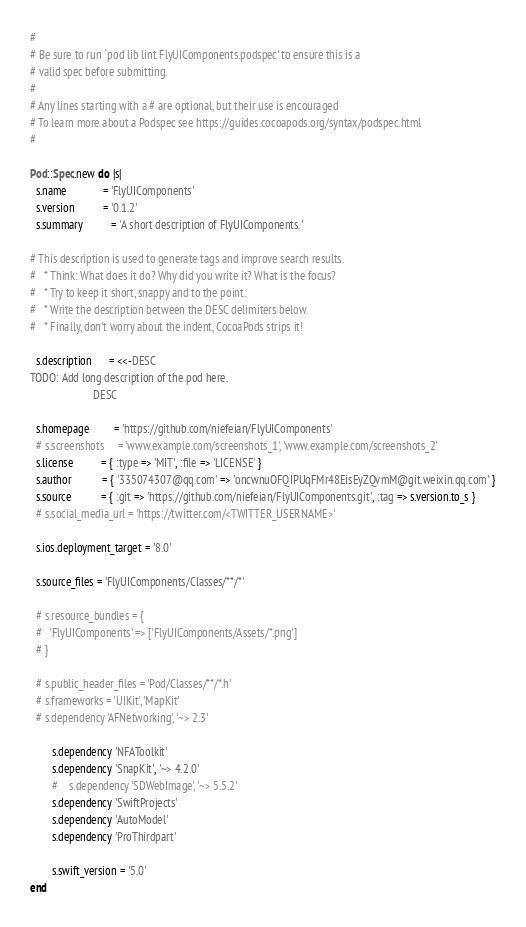Convert code to text. <code><loc_0><loc_0><loc_500><loc_500><_Ruby_>#
# Be sure to run `pod lib lint FlyUIComponents.podspec' to ensure this is a
# valid spec before submitting.
#
# Any lines starting with a # are optional, but their use is encouraged
# To learn more about a Podspec see https://guides.cocoapods.org/syntax/podspec.html
#

Pod::Spec.new do |s|
  s.name             = 'FlyUIComponents'
  s.version          = '0.1.2'
  s.summary          = 'A short description of FlyUIComponents.'

# This description is used to generate tags and improve search results.
#   * Think: What does it do? Why did you write it? What is the focus?
#   * Try to keep it short, snappy and to the point.
#   * Write the description between the DESC delimiters below.
#   * Finally, don't worry about the indent, CocoaPods strips it!

  s.description      = <<-DESC
TODO: Add long description of the pod here.
                       DESC

  s.homepage         = 'https://github.com/niefeian/FlyUIComponents'
  # s.screenshots     = 'www.example.com/screenshots_1', 'www.example.com/screenshots_2'
  s.license          = { :type => 'MIT', :file => 'LICENSE' }
  s.author           = { '335074307@qq.com' => 'oncwnuOFQIPUqFMr48EisEyZQvmM@git.weixin.qq.com' }
  s.source           = { :git => 'https://github.com/niefeian/FlyUIComponents.git', :tag => s.version.to_s }
  # s.social_media_url = 'https://twitter.com/<TWITTER_USERNAME>'

  s.ios.deployment_target = '8.0'

  s.source_files = 'FlyUIComponents/Classes/**/*'
  
  # s.resource_bundles = {
  #   'FlyUIComponents' => ['FlyUIComponents/Assets/*.png']
  # }

  # s.public_header_files = 'Pod/Classes/**/*.h'
  # s.frameworks = 'UIKit', 'MapKit'
  # s.dependency 'AFNetworking', '~> 2.3'
  
        s.dependency 'NFAToolkit'
        s.dependency 'SnapKit', '~> 4.2.0'
        #    s.dependency 'SDWebImage', '~> 5.5.2'
        s.dependency 'SwiftProjects'
        s.dependency 'AutoModel'
        s.dependency 'ProThirdpart'

        s.swift_version = '5.0'
end
</code> 